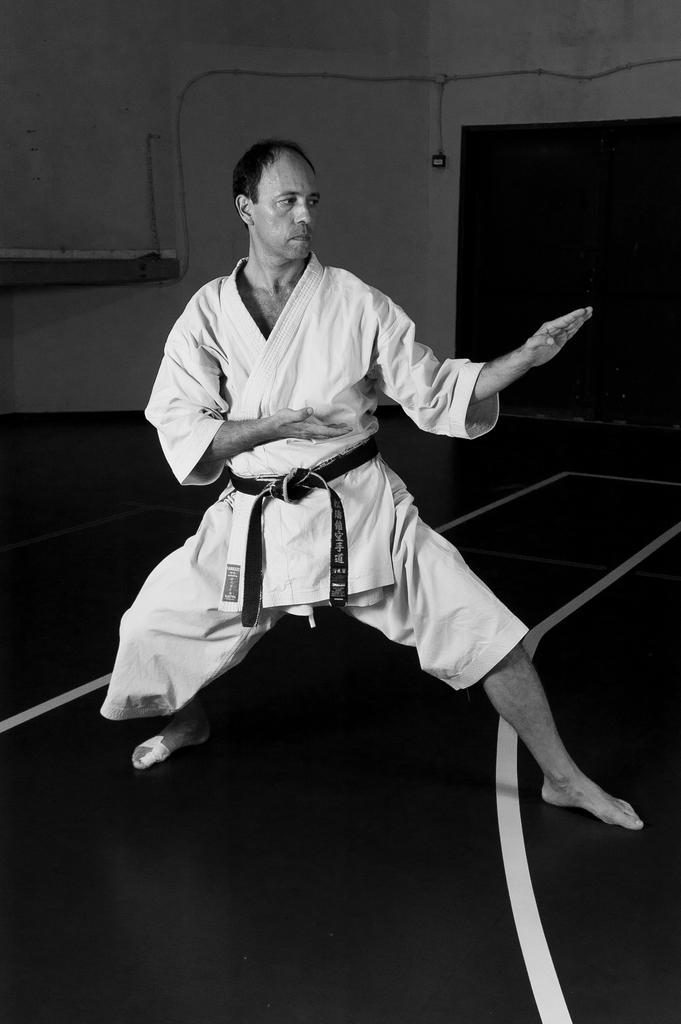What is the color scheme of the image? The image is black and white. Can you describe the person in the image? There is a person in the image, and they are looking towards the right side. What can be seen in the background of the image? There is a wall in the background of the image. How many frogs are sitting on the plants in the image? There are no frogs or plants present in the image; it is a black and white image of a person looking towards the right side with a wall in the background. 